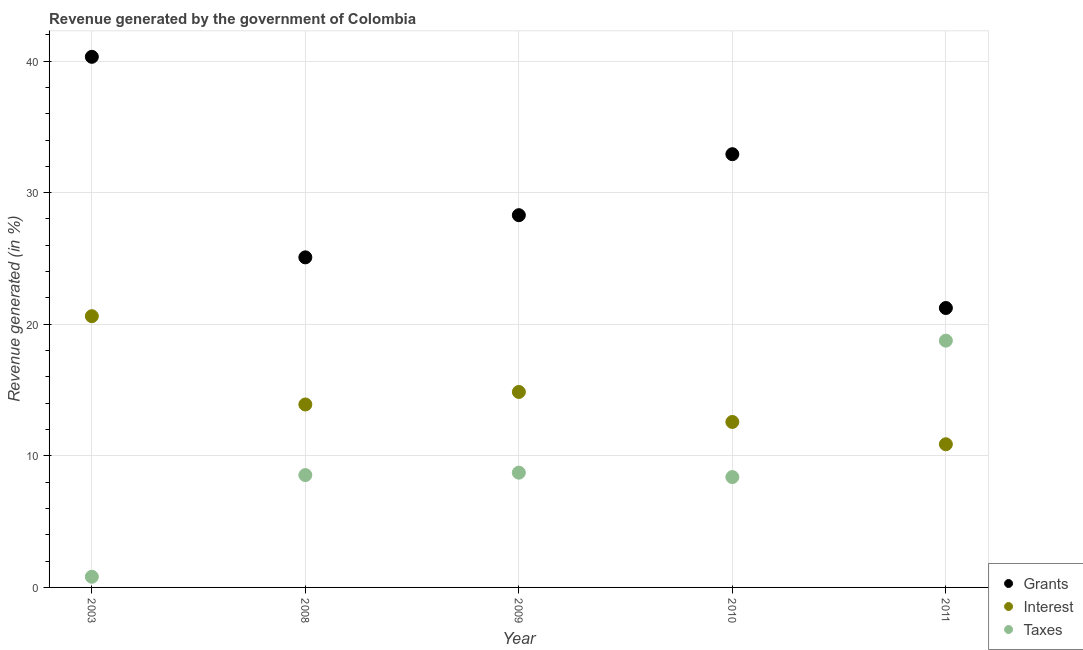How many different coloured dotlines are there?
Ensure brevity in your answer.  3. Is the number of dotlines equal to the number of legend labels?
Your answer should be compact. Yes. What is the percentage of revenue generated by grants in 2011?
Your response must be concise. 21.23. Across all years, what is the maximum percentage of revenue generated by grants?
Keep it short and to the point. 40.32. Across all years, what is the minimum percentage of revenue generated by grants?
Your answer should be very brief. 21.23. In which year was the percentage of revenue generated by interest maximum?
Your response must be concise. 2003. In which year was the percentage of revenue generated by taxes minimum?
Ensure brevity in your answer.  2003. What is the total percentage of revenue generated by taxes in the graph?
Provide a succinct answer. 45.21. What is the difference between the percentage of revenue generated by taxes in 2003 and that in 2009?
Make the answer very short. -7.91. What is the difference between the percentage of revenue generated by grants in 2003 and the percentage of revenue generated by interest in 2008?
Your answer should be very brief. 26.42. What is the average percentage of revenue generated by grants per year?
Make the answer very short. 29.57. In the year 2009, what is the difference between the percentage of revenue generated by grants and percentage of revenue generated by interest?
Offer a terse response. 13.43. What is the ratio of the percentage of revenue generated by grants in 2003 to that in 2008?
Make the answer very short. 1.61. Is the percentage of revenue generated by grants in 2008 less than that in 2010?
Ensure brevity in your answer.  Yes. What is the difference between the highest and the second highest percentage of revenue generated by grants?
Keep it short and to the point. 7.4. What is the difference between the highest and the lowest percentage of revenue generated by grants?
Make the answer very short. 19.09. In how many years, is the percentage of revenue generated by grants greater than the average percentage of revenue generated by grants taken over all years?
Offer a terse response. 2. Is the sum of the percentage of revenue generated by interest in 2008 and 2011 greater than the maximum percentage of revenue generated by grants across all years?
Your answer should be compact. No. Does the percentage of revenue generated by interest monotonically increase over the years?
Your answer should be compact. No. Is the percentage of revenue generated by interest strictly less than the percentage of revenue generated by taxes over the years?
Your response must be concise. No. How many dotlines are there?
Provide a succinct answer. 3. What is the difference between two consecutive major ticks on the Y-axis?
Your answer should be compact. 10. Are the values on the major ticks of Y-axis written in scientific E-notation?
Give a very brief answer. No. Does the graph contain any zero values?
Provide a short and direct response. No. Does the graph contain grids?
Your response must be concise. Yes. How many legend labels are there?
Offer a terse response. 3. What is the title of the graph?
Give a very brief answer. Revenue generated by the government of Colombia. What is the label or title of the X-axis?
Make the answer very short. Year. What is the label or title of the Y-axis?
Provide a succinct answer. Revenue generated (in %). What is the Revenue generated (in %) in Grants in 2003?
Provide a short and direct response. 40.32. What is the Revenue generated (in %) in Interest in 2003?
Offer a terse response. 20.61. What is the Revenue generated (in %) of Taxes in 2003?
Your response must be concise. 0.81. What is the Revenue generated (in %) of Grants in 2008?
Give a very brief answer. 25.08. What is the Revenue generated (in %) in Interest in 2008?
Offer a very short reply. 13.9. What is the Revenue generated (in %) in Taxes in 2008?
Provide a short and direct response. 8.54. What is the Revenue generated (in %) in Grants in 2009?
Your response must be concise. 28.29. What is the Revenue generated (in %) in Interest in 2009?
Your answer should be very brief. 14.86. What is the Revenue generated (in %) of Taxes in 2009?
Give a very brief answer. 8.72. What is the Revenue generated (in %) in Grants in 2010?
Ensure brevity in your answer.  32.92. What is the Revenue generated (in %) in Interest in 2010?
Provide a short and direct response. 12.57. What is the Revenue generated (in %) of Taxes in 2010?
Ensure brevity in your answer.  8.39. What is the Revenue generated (in %) in Grants in 2011?
Keep it short and to the point. 21.23. What is the Revenue generated (in %) in Interest in 2011?
Keep it short and to the point. 10.88. What is the Revenue generated (in %) in Taxes in 2011?
Offer a terse response. 18.75. Across all years, what is the maximum Revenue generated (in %) of Grants?
Ensure brevity in your answer.  40.32. Across all years, what is the maximum Revenue generated (in %) of Interest?
Give a very brief answer. 20.61. Across all years, what is the maximum Revenue generated (in %) of Taxes?
Your answer should be very brief. 18.75. Across all years, what is the minimum Revenue generated (in %) of Grants?
Ensure brevity in your answer.  21.23. Across all years, what is the minimum Revenue generated (in %) of Interest?
Keep it short and to the point. 10.88. Across all years, what is the minimum Revenue generated (in %) of Taxes?
Your answer should be compact. 0.81. What is the total Revenue generated (in %) of Grants in the graph?
Provide a short and direct response. 147.85. What is the total Revenue generated (in %) of Interest in the graph?
Ensure brevity in your answer.  72.83. What is the total Revenue generated (in %) of Taxes in the graph?
Your answer should be compact. 45.21. What is the difference between the Revenue generated (in %) of Grants in 2003 and that in 2008?
Your answer should be very brief. 15.24. What is the difference between the Revenue generated (in %) in Interest in 2003 and that in 2008?
Offer a terse response. 6.71. What is the difference between the Revenue generated (in %) in Taxes in 2003 and that in 2008?
Make the answer very short. -7.73. What is the difference between the Revenue generated (in %) in Grants in 2003 and that in 2009?
Ensure brevity in your answer.  12.03. What is the difference between the Revenue generated (in %) in Interest in 2003 and that in 2009?
Your response must be concise. 5.76. What is the difference between the Revenue generated (in %) in Taxes in 2003 and that in 2009?
Offer a very short reply. -7.91. What is the difference between the Revenue generated (in %) in Grants in 2003 and that in 2010?
Make the answer very short. 7.4. What is the difference between the Revenue generated (in %) of Interest in 2003 and that in 2010?
Your response must be concise. 8.04. What is the difference between the Revenue generated (in %) of Taxes in 2003 and that in 2010?
Your answer should be compact. -7.58. What is the difference between the Revenue generated (in %) in Grants in 2003 and that in 2011?
Your answer should be very brief. 19.09. What is the difference between the Revenue generated (in %) of Interest in 2003 and that in 2011?
Make the answer very short. 9.73. What is the difference between the Revenue generated (in %) in Taxes in 2003 and that in 2011?
Make the answer very short. -17.94. What is the difference between the Revenue generated (in %) of Grants in 2008 and that in 2009?
Your answer should be very brief. -3.2. What is the difference between the Revenue generated (in %) in Interest in 2008 and that in 2009?
Offer a very short reply. -0.95. What is the difference between the Revenue generated (in %) in Taxes in 2008 and that in 2009?
Provide a succinct answer. -0.18. What is the difference between the Revenue generated (in %) in Grants in 2008 and that in 2010?
Your answer should be compact. -7.84. What is the difference between the Revenue generated (in %) of Interest in 2008 and that in 2010?
Your answer should be very brief. 1.33. What is the difference between the Revenue generated (in %) in Taxes in 2008 and that in 2010?
Ensure brevity in your answer.  0.15. What is the difference between the Revenue generated (in %) of Grants in 2008 and that in 2011?
Your response must be concise. 3.85. What is the difference between the Revenue generated (in %) in Interest in 2008 and that in 2011?
Give a very brief answer. 3.02. What is the difference between the Revenue generated (in %) in Taxes in 2008 and that in 2011?
Keep it short and to the point. -10.22. What is the difference between the Revenue generated (in %) of Grants in 2009 and that in 2010?
Offer a terse response. -4.63. What is the difference between the Revenue generated (in %) in Interest in 2009 and that in 2010?
Make the answer very short. 2.28. What is the difference between the Revenue generated (in %) of Taxes in 2009 and that in 2010?
Ensure brevity in your answer.  0.33. What is the difference between the Revenue generated (in %) of Grants in 2009 and that in 2011?
Ensure brevity in your answer.  7.05. What is the difference between the Revenue generated (in %) in Interest in 2009 and that in 2011?
Provide a succinct answer. 3.98. What is the difference between the Revenue generated (in %) of Taxes in 2009 and that in 2011?
Offer a very short reply. -10.03. What is the difference between the Revenue generated (in %) of Grants in 2010 and that in 2011?
Provide a short and direct response. 11.69. What is the difference between the Revenue generated (in %) in Interest in 2010 and that in 2011?
Provide a succinct answer. 1.69. What is the difference between the Revenue generated (in %) in Taxes in 2010 and that in 2011?
Make the answer very short. -10.37. What is the difference between the Revenue generated (in %) of Grants in 2003 and the Revenue generated (in %) of Interest in 2008?
Make the answer very short. 26.42. What is the difference between the Revenue generated (in %) of Grants in 2003 and the Revenue generated (in %) of Taxes in 2008?
Offer a very short reply. 31.78. What is the difference between the Revenue generated (in %) in Interest in 2003 and the Revenue generated (in %) in Taxes in 2008?
Ensure brevity in your answer.  12.07. What is the difference between the Revenue generated (in %) in Grants in 2003 and the Revenue generated (in %) in Interest in 2009?
Offer a very short reply. 25.47. What is the difference between the Revenue generated (in %) of Grants in 2003 and the Revenue generated (in %) of Taxes in 2009?
Offer a terse response. 31.6. What is the difference between the Revenue generated (in %) in Interest in 2003 and the Revenue generated (in %) in Taxes in 2009?
Offer a very short reply. 11.89. What is the difference between the Revenue generated (in %) in Grants in 2003 and the Revenue generated (in %) in Interest in 2010?
Your response must be concise. 27.75. What is the difference between the Revenue generated (in %) of Grants in 2003 and the Revenue generated (in %) of Taxes in 2010?
Keep it short and to the point. 31.94. What is the difference between the Revenue generated (in %) of Interest in 2003 and the Revenue generated (in %) of Taxes in 2010?
Your response must be concise. 12.23. What is the difference between the Revenue generated (in %) of Grants in 2003 and the Revenue generated (in %) of Interest in 2011?
Keep it short and to the point. 29.44. What is the difference between the Revenue generated (in %) in Grants in 2003 and the Revenue generated (in %) in Taxes in 2011?
Give a very brief answer. 21.57. What is the difference between the Revenue generated (in %) in Interest in 2003 and the Revenue generated (in %) in Taxes in 2011?
Ensure brevity in your answer.  1.86. What is the difference between the Revenue generated (in %) in Grants in 2008 and the Revenue generated (in %) in Interest in 2009?
Keep it short and to the point. 10.23. What is the difference between the Revenue generated (in %) in Grants in 2008 and the Revenue generated (in %) in Taxes in 2009?
Make the answer very short. 16.36. What is the difference between the Revenue generated (in %) of Interest in 2008 and the Revenue generated (in %) of Taxes in 2009?
Your response must be concise. 5.18. What is the difference between the Revenue generated (in %) of Grants in 2008 and the Revenue generated (in %) of Interest in 2010?
Give a very brief answer. 12.51. What is the difference between the Revenue generated (in %) in Grants in 2008 and the Revenue generated (in %) in Taxes in 2010?
Provide a succinct answer. 16.7. What is the difference between the Revenue generated (in %) in Interest in 2008 and the Revenue generated (in %) in Taxes in 2010?
Your answer should be very brief. 5.52. What is the difference between the Revenue generated (in %) of Grants in 2008 and the Revenue generated (in %) of Interest in 2011?
Keep it short and to the point. 14.2. What is the difference between the Revenue generated (in %) of Grants in 2008 and the Revenue generated (in %) of Taxes in 2011?
Offer a very short reply. 6.33. What is the difference between the Revenue generated (in %) in Interest in 2008 and the Revenue generated (in %) in Taxes in 2011?
Offer a very short reply. -4.85. What is the difference between the Revenue generated (in %) of Grants in 2009 and the Revenue generated (in %) of Interest in 2010?
Give a very brief answer. 15.71. What is the difference between the Revenue generated (in %) of Grants in 2009 and the Revenue generated (in %) of Taxes in 2010?
Provide a short and direct response. 19.9. What is the difference between the Revenue generated (in %) in Interest in 2009 and the Revenue generated (in %) in Taxes in 2010?
Ensure brevity in your answer.  6.47. What is the difference between the Revenue generated (in %) of Grants in 2009 and the Revenue generated (in %) of Interest in 2011?
Your answer should be very brief. 17.41. What is the difference between the Revenue generated (in %) in Grants in 2009 and the Revenue generated (in %) in Taxes in 2011?
Ensure brevity in your answer.  9.53. What is the difference between the Revenue generated (in %) of Interest in 2009 and the Revenue generated (in %) of Taxes in 2011?
Your answer should be very brief. -3.9. What is the difference between the Revenue generated (in %) in Grants in 2010 and the Revenue generated (in %) in Interest in 2011?
Keep it short and to the point. 22.04. What is the difference between the Revenue generated (in %) in Grants in 2010 and the Revenue generated (in %) in Taxes in 2011?
Make the answer very short. 14.17. What is the difference between the Revenue generated (in %) in Interest in 2010 and the Revenue generated (in %) in Taxes in 2011?
Make the answer very short. -6.18. What is the average Revenue generated (in %) of Grants per year?
Offer a very short reply. 29.57. What is the average Revenue generated (in %) in Interest per year?
Give a very brief answer. 14.57. What is the average Revenue generated (in %) in Taxes per year?
Your answer should be compact. 9.04. In the year 2003, what is the difference between the Revenue generated (in %) of Grants and Revenue generated (in %) of Interest?
Your answer should be compact. 19.71. In the year 2003, what is the difference between the Revenue generated (in %) in Grants and Revenue generated (in %) in Taxes?
Make the answer very short. 39.51. In the year 2003, what is the difference between the Revenue generated (in %) of Interest and Revenue generated (in %) of Taxes?
Offer a very short reply. 19.8. In the year 2008, what is the difference between the Revenue generated (in %) in Grants and Revenue generated (in %) in Interest?
Offer a terse response. 11.18. In the year 2008, what is the difference between the Revenue generated (in %) in Grants and Revenue generated (in %) in Taxes?
Your answer should be compact. 16.55. In the year 2008, what is the difference between the Revenue generated (in %) of Interest and Revenue generated (in %) of Taxes?
Give a very brief answer. 5.36. In the year 2009, what is the difference between the Revenue generated (in %) in Grants and Revenue generated (in %) in Interest?
Make the answer very short. 13.43. In the year 2009, what is the difference between the Revenue generated (in %) of Grants and Revenue generated (in %) of Taxes?
Keep it short and to the point. 19.57. In the year 2009, what is the difference between the Revenue generated (in %) of Interest and Revenue generated (in %) of Taxes?
Your answer should be compact. 6.13. In the year 2010, what is the difference between the Revenue generated (in %) in Grants and Revenue generated (in %) in Interest?
Your answer should be compact. 20.35. In the year 2010, what is the difference between the Revenue generated (in %) in Grants and Revenue generated (in %) in Taxes?
Your answer should be very brief. 24.54. In the year 2010, what is the difference between the Revenue generated (in %) of Interest and Revenue generated (in %) of Taxes?
Offer a very short reply. 4.19. In the year 2011, what is the difference between the Revenue generated (in %) in Grants and Revenue generated (in %) in Interest?
Provide a short and direct response. 10.35. In the year 2011, what is the difference between the Revenue generated (in %) of Grants and Revenue generated (in %) of Taxes?
Offer a terse response. 2.48. In the year 2011, what is the difference between the Revenue generated (in %) of Interest and Revenue generated (in %) of Taxes?
Offer a terse response. -7.87. What is the ratio of the Revenue generated (in %) of Grants in 2003 to that in 2008?
Your answer should be very brief. 1.61. What is the ratio of the Revenue generated (in %) of Interest in 2003 to that in 2008?
Your answer should be very brief. 1.48. What is the ratio of the Revenue generated (in %) in Taxes in 2003 to that in 2008?
Give a very brief answer. 0.09. What is the ratio of the Revenue generated (in %) in Grants in 2003 to that in 2009?
Give a very brief answer. 1.43. What is the ratio of the Revenue generated (in %) in Interest in 2003 to that in 2009?
Provide a succinct answer. 1.39. What is the ratio of the Revenue generated (in %) in Taxes in 2003 to that in 2009?
Provide a succinct answer. 0.09. What is the ratio of the Revenue generated (in %) of Grants in 2003 to that in 2010?
Give a very brief answer. 1.22. What is the ratio of the Revenue generated (in %) in Interest in 2003 to that in 2010?
Provide a succinct answer. 1.64. What is the ratio of the Revenue generated (in %) in Taxes in 2003 to that in 2010?
Give a very brief answer. 0.1. What is the ratio of the Revenue generated (in %) in Grants in 2003 to that in 2011?
Give a very brief answer. 1.9. What is the ratio of the Revenue generated (in %) in Interest in 2003 to that in 2011?
Provide a succinct answer. 1.89. What is the ratio of the Revenue generated (in %) of Taxes in 2003 to that in 2011?
Ensure brevity in your answer.  0.04. What is the ratio of the Revenue generated (in %) of Grants in 2008 to that in 2009?
Keep it short and to the point. 0.89. What is the ratio of the Revenue generated (in %) of Interest in 2008 to that in 2009?
Your answer should be compact. 0.94. What is the ratio of the Revenue generated (in %) in Taxes in 2008 to that in 2009?
Your answer should be compact. 0.98. What is the ratio of the Revenue generated (in %) in Grants in 2008 to that in 2010?
Your response must be concise. 0.76. What is the ratio of the Revenue generated (in %) in Interest in 2008 to that in 2010?
Your response must be concise. 1.11. What is the ratio of the Revenue generated (in %) of Taxes in 2008 to that in 2010?
Make the answer very short. 1.02. What is the ratio of the Revenue generated (in %) in Grants in 2008 to that in 2011?
Your answer should be compact. 1.18. What is the ratio of the Revenue generated (in %) in Interest in 2008 to that in 2011?
Offer a terse response. 1.28. What is the ratio of the Revenue generated (in %) of Taxes in 2008 to that in 2011?
Your response must be concise. 0.46. What is the ratio of the Revenue generated (in %) in Grants in 2009 to that in 2010?
Make the answer very short. 0.86. What is the ratio of the Revenue generated (in %) of Interest in 2009 to that in 2010?
Offer a very short reply. 1.18. What is the ratio of the Revenue generated (in %) of Taxes in 2009 to that in 2010?
Your answer should be very brief. 1.04. What is the ratio of the Revenue generated (in %) of Grants in 2009 to that in 2011?
Your response must be concise. 1.33. What is the ratio of the Revenue generated (in %) in Interest in 2009 to that in 2011?
Your answer should be compact. 1.37. What is the ratio of the Revenue generated (in %) in Taxes in 2009 to that in 2011?
Your response must be concise. 0.47. What is the ratio of the Revenue generated (in %) of Grants in 2010 to that in 2011?
Your answer should be very brief. 1.55. What is the ratio of the Revenue generated (in %) of Interest in 2010 to that in 2011?
Your response must be concise. 1.16. What is the ratio of the Revenue generated (in %) in Taxes in 2010 to that in 2011?
Provide a short and direct response. 0.45. What is the difference between the highest and the second highest Revenue generated (in %) in Grants?
Offer a terse response. 7.4. What is the difference between the highest and the second highest Revenue generated (in %) of Interest?
Offer a terse response. 5.76. What is the difference between the highest and the second highest Revenue generated (in %) in Taxes?
Provide a succinct answer. 10.03. What is the difference between the highest and the lowest Revenue generated (in %) of Grants?
Your answer should be very brief. 19.09. What is the difference between the highest and the lowest Revenue generated (in %) of Interest?
Your response must be concise. 9.73. What is the difference between the highest and the lowest Revenue generated (in %) of Taxes?
Give a very brief answer. 17.94. 